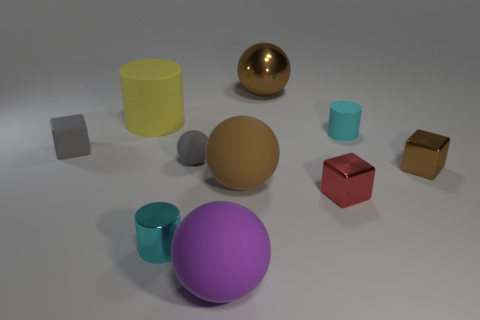Subtract all brown shiny balls. How many balls are left? 3 Subtract all purple cubes. How many cyan cylinders are left? 2 Subtract all purple spheres. How many spheres are left? 3 Subtract 1 cubes. How many cubes are left? 2 Subtract all yellow blocks. Subtract all red balls. How many blocks are left? 3 Subtract all balls. How many objects are left? 6 Add 4 small gray matte blocks. How many small gray matte blocks are left? 5 Add 1 matte blocks. How many matte blocks exist? 2 Subtract 1 purple spheres. How many objects are left? 9 Subtract all red shiny cylinders. Subtract all tiny cyan metal things. How many objects are left? 9 